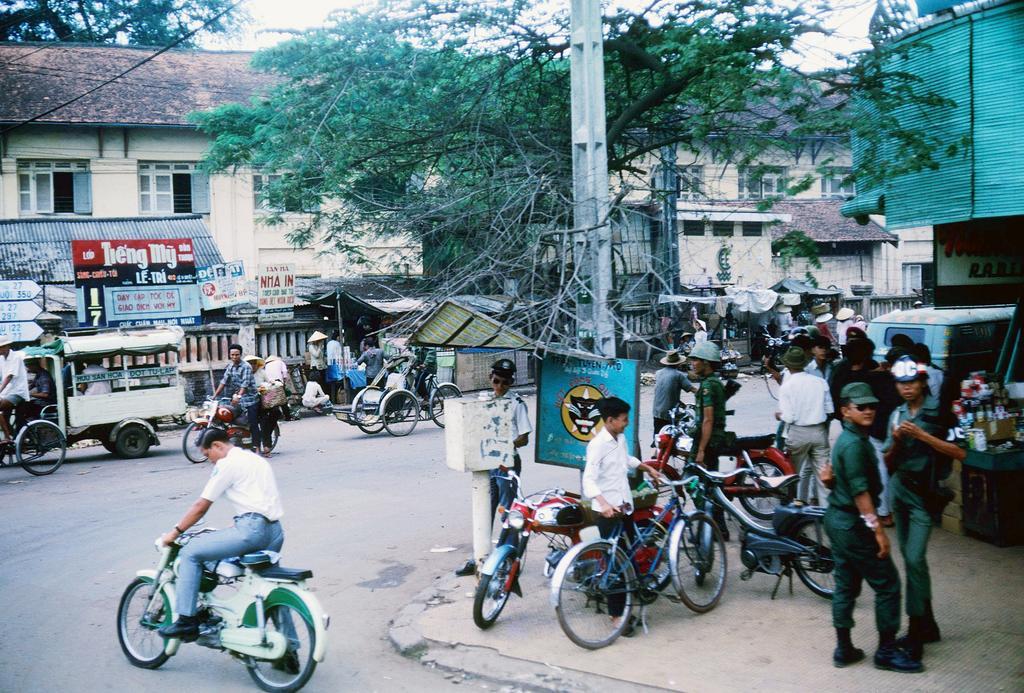In one or two sentences, can you explain what this image depicts? Here we can see some persons are standing on the road. There are bikes and bicycles. Here we can see a man riding a bike. There is a vehicle. This is pole and there is a board. This is building and there are windows. There are trees and this is sky. 